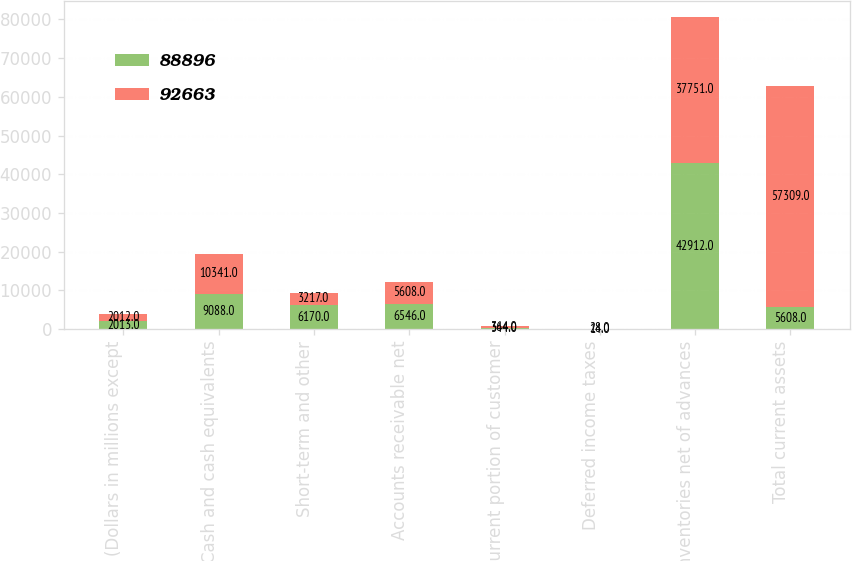<chart> <loc_0><loc_0><loc_500><loc_500><stacked_bar_chart><ecel><fcel>(Dollars in millions except<fcel>Cash and cash equivalents<fcel>Short-term and other<fcel>Accounts receivable net<fcel>Current portion of customer<fcel>Deferred income taxes<fcel>Inventories net of advances<fcel>Total current assets<nl><fcel>88896<fcel>2013<fcel>9088<fcel>6170<fcel>6546<fcel>344<fcel>14<fcel>42912<fcel>5608<nl><fcel>92663<fcel>2012<fcel>10341<fcel>3217<fcel>5608<fcel>364<fcel>28<fcel>37751<fcel>57309<nl></chart> 